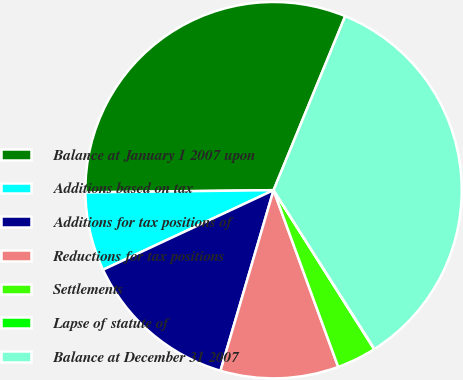Convert chart to OTSL. <chart><loc_0><loc_0><loc_500><loc_500><pie_chart><fcel>Balance at January 1 2007 upon<fcel>Additions based on tax<fcel>Additions for tax positions of<fcel>Reductions for tax positions<fcel>Settlements<fcel>Lapse of statute of<fcel>Balance at December 31 2007<nl><fcel>31.4%<fcel>6.76%<fcel>13.5%<fcel>10.13%<fcel>3.4%<fcel>0.03%<fcel>34.77%<nl></chart> 